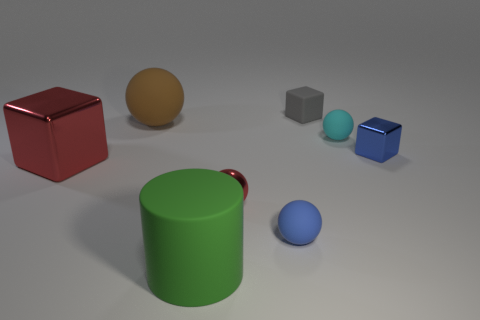What number of tiny blue metallic cubes are left of the block that is on the left side of the small object on the left side of the tiny blue sphere?
Offer a terse response. 0. Is the size of the red sphere the same as the metal cube on the left side of the tiny cyan rubber sphere?
Offer a terse response. No. What number of tiny metallic blocks are there?
Offer a terse response. 1. There is a shiny cube in front of the small metallic cube; is its size the same as the brown rubber object that is in front of the small gray thing?
Ensure brevity in your answer.  Yes. The large metallic object that is the same shape as the small blue shiny thing is what color?
Keep it short and to the point. Red. Does the large green rubber object have the same shape as the cyan object?
Provide a succinct answer. No. There is a cyan matte object that is the same shape as the brown object; what size is it?
Your answer should be compact. Small. How many big cylinders have the same material as the big red block?
Provide a succinct answer. 0. How many objects are small blue cubes or cyan spheres?
Ensure brevity in your answer.  2. Are there any tiny cubes to the right of the cube that is to the left of the big green thing?
Make the answer very short. Yes. 